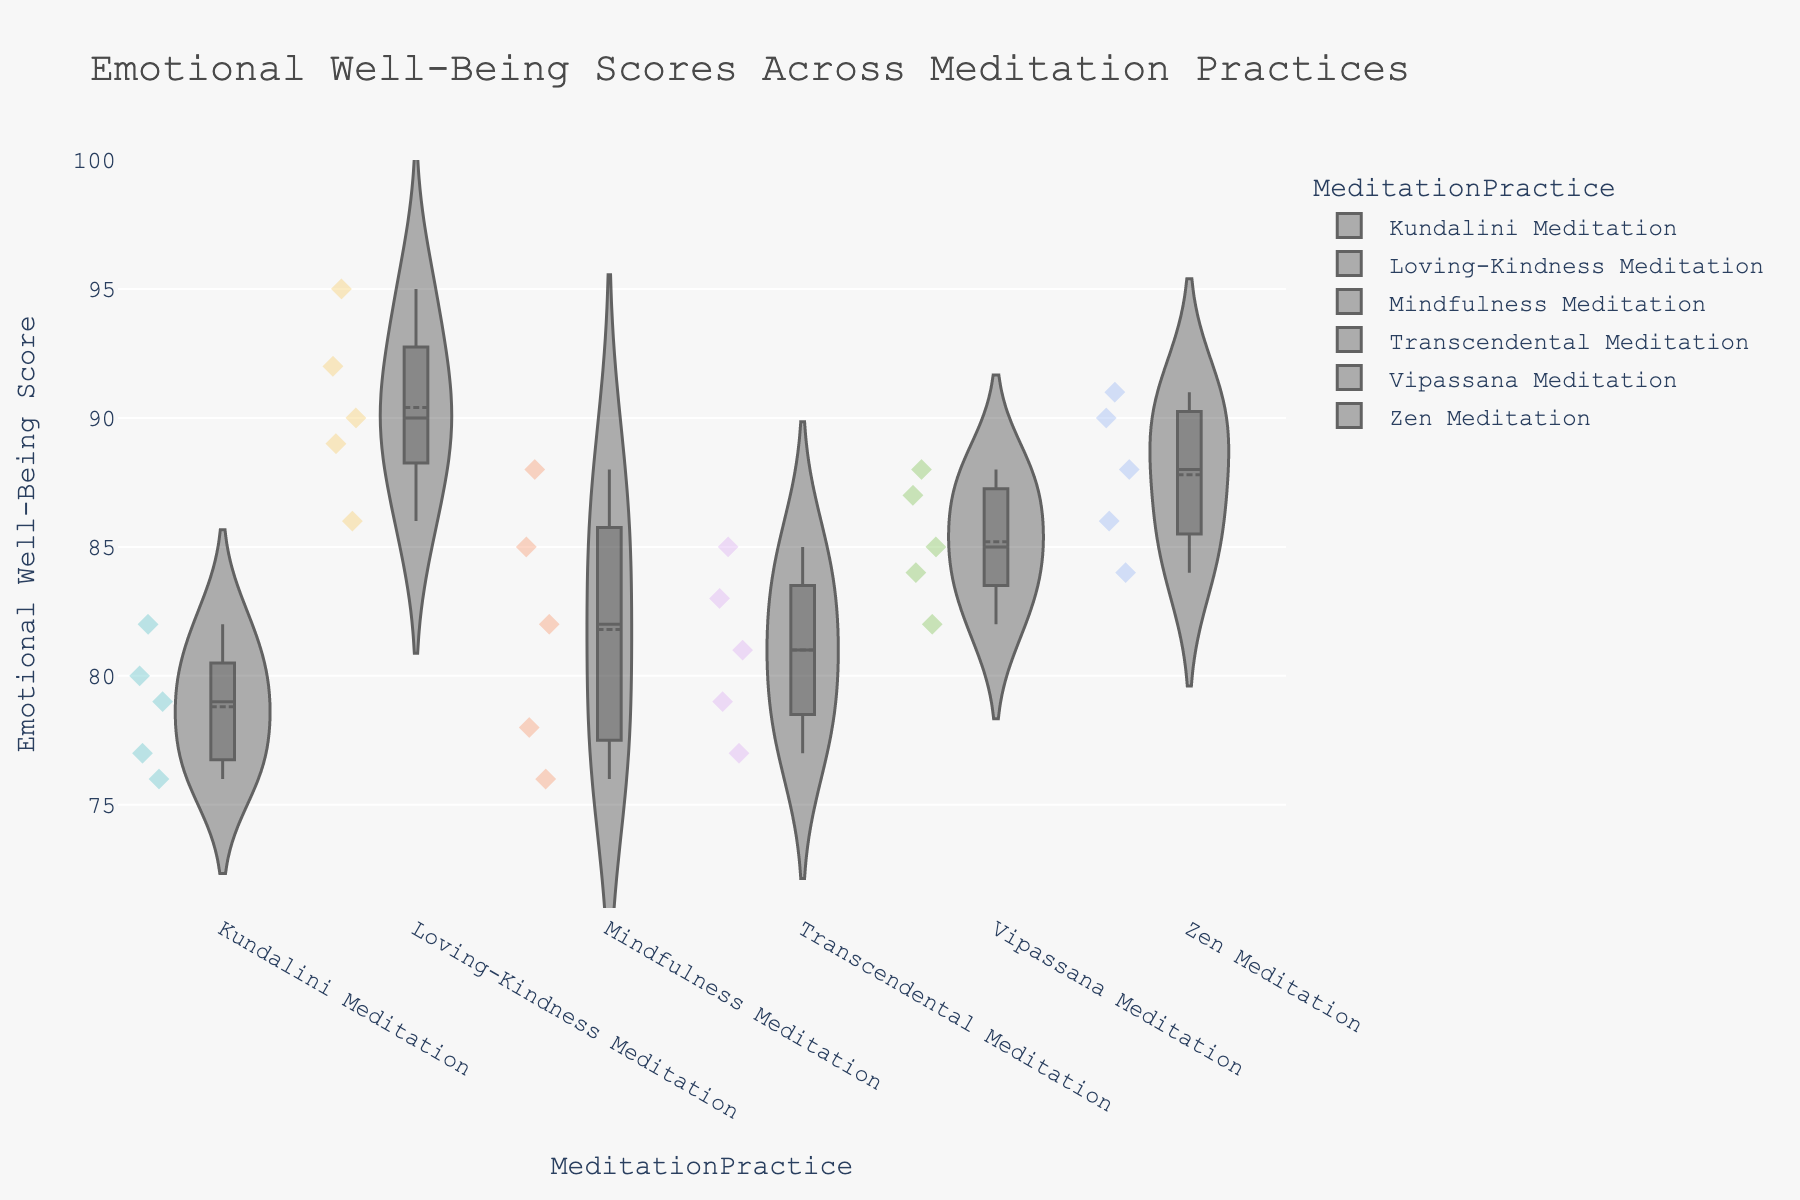What is the title of the figure? The title is displayed at the top of the figure and states the main focus of the visualization.
Answer: Emotional Well-Being Scores Across Meditation Practices Which meditation practice has the highest median emotional well-being score? The median is represented by a central line in the violet plots. By observing these lines, we can identify the highest one.
Answer: Loving-Kindness Meditation How many data points are there for Mindfulness Meditation? Each dot within the violin plot represents a data point. Counting all the dots for this group will give the number of points.
Answer: 5 Which meditation practice has the widest spread in emotional well-being scores? The spread is judged by the width of the violin plot. The wider the plot, the more variability there is in that group's scores.
Answer: Mindfulness Meditation What is the range of emotional well-being scores for Kundalini Meditation? The range is the difference between the maximum and minimum scores observed. The topmost and bottommost points give these values respectively.
Answer: 76 to 82 Which meditation practice has the lowest minimum emotional well-being score? The lowest minimum score can be identified by finding the lowest point across all violin plots.
Answer: Kundalini Meditation Which two meditation practices have overlapping distributions? Overlapping distributions can be identified by examining where the violin plots intersect or overlap.
Answer: Transcendental Meditation and Zen Meditation What is the mean emotional well-being score for Vipassana Meditation? The mean score is represented by a horizontal line within the box plot inside the violin plot. Observing this line for Vipassana Meditation will give the mean.
Answer: 85 Which meditation practice shows the least variability in emotional well-being scores? The least variability can be found by looking for the narrowest violin plot, which indicates less spread in the scores.
Answer: Loving-Kindness Meditation Are there any outliers in the data for any meditation practice, and if so, which one(s)? Outliers are often represented by points outside the main bulk of the violin plot, sometimes marked individually.
Answer: No outliers 